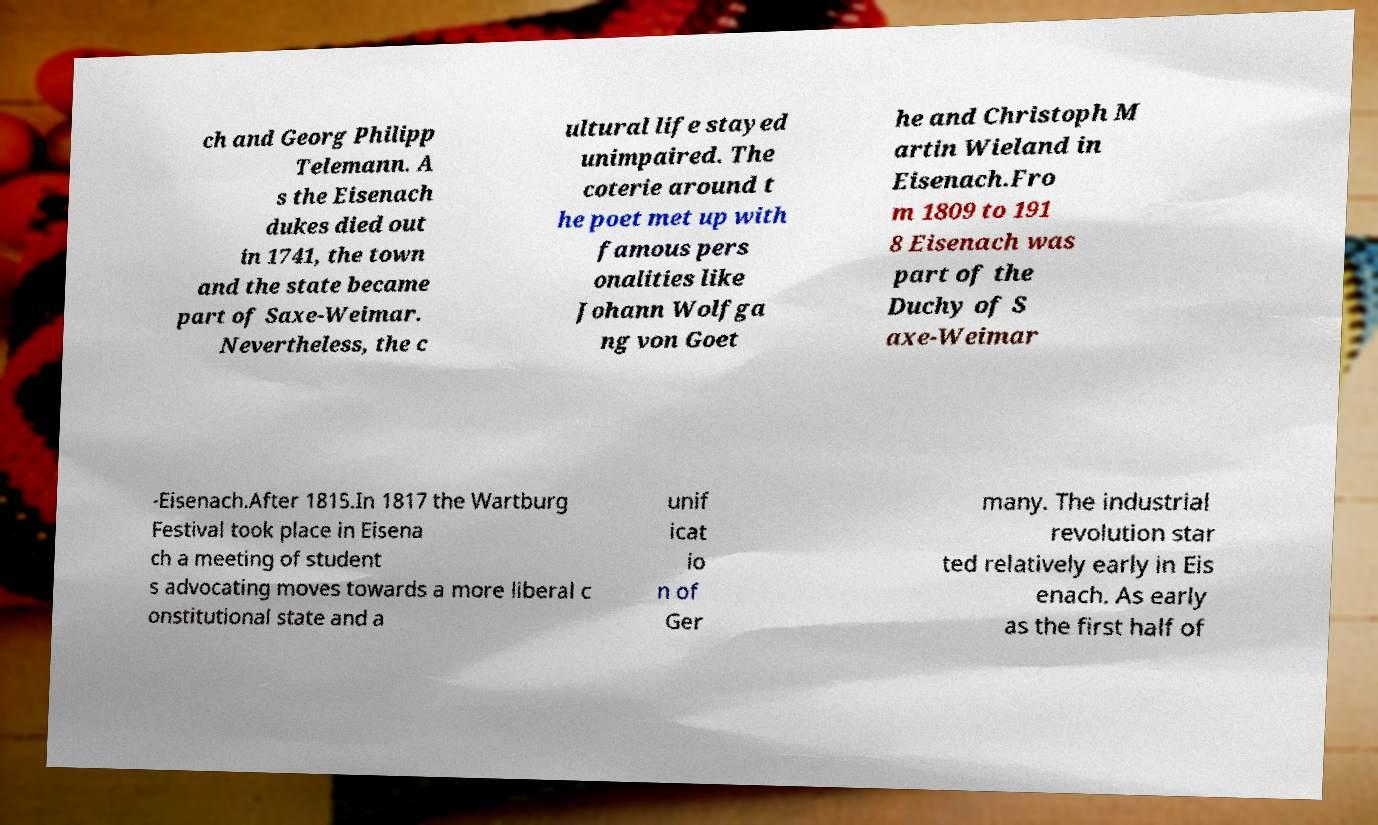For documentation purposes, I need the text within this image transcribed. Could you provide that? ch and Georg Philipp Telemann. A s the Eisenach dukes died out in 1741, the town and the state became part of Saxe-Weimar. Nevertheless, the c ultural life stayed unimpaired. The coterie around t he poet met up with famous pers onalities like Johann Wolfga ng von Goet he and Christoph M artin Wieland in Eisenach.Fro m 1809 to 191 8 Eisenach was part of the Duchy of S axe-Weimar -Eisenach.After 1815.In 1817 the Wartburg Festival took place in Eisena ch a meeting of student s advocating moves towards a more liberal c onstitutional state and a unif icat io n of Ger many. The industrial revolution star ted relatively early in Eis enach. As early as the first half of 